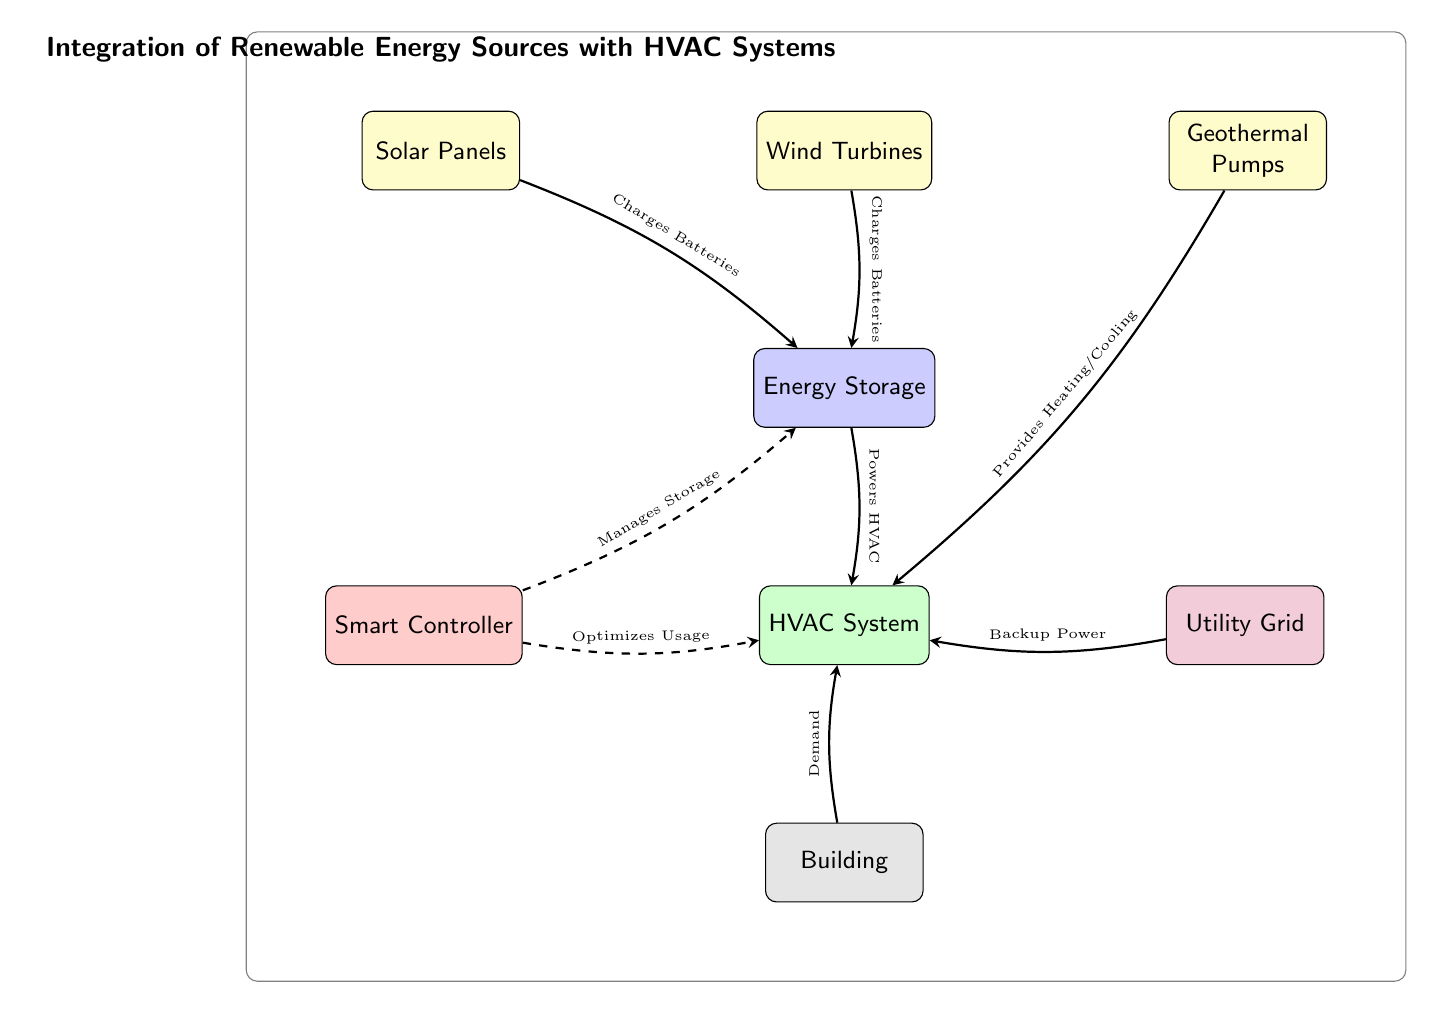What are the energy sources integrated into the HVAC system? The diagram shows three energy sources: Solar Panels, Wind Turbines, and Geothermal Pumps. Each of these is labeled as an energy source, directly connected through arrows to the respective nodes for their functions.
Answer: Solar Panels, Wind Turbines, Geothermal Pumps What function does the Smart Controller serve in this diagram? The Smart Controller is connected to both the HVAC System and the Energy Storage, with arrows indicating its management roles. It is labeled as optimizing usage and managing storage within the system.
Answer: Optimizes Usage, Manages Storage How many energy sources are shown in the diagram? By counting the nodes labeled as energy sources (Solar Panels, Wind Turbines, Geothermal Pumps), there are a total of three distinct sources represented in the diagram.
Answer: 3 What does the Energy Storage do in relation to the HVAC System? The Energy Storage node is connected to the HVAC System via a flow arrow, indicating that it provides power to the HVAC System. The label on the arrow confirms this function explicitly, stating it powers the HVAC.
Answer: Powers HVAC What type of backup does the HVAC System have? The HVAC System is connected to a Utility Grid node with a flow arrow, which indicates that it has backup power supplied from the grid. The label on the arrow specifies this capacity, confirming that the grid acts as a backup.
Answer: Backup Power Which energy source provides heating or cooling directly to the HVAC System? The Geothermal Pumps node has an arrow directly pointing towards the HVAC System, specifically labeled as providing heating/cooling. This means it is a crucial source for temperature regulation in the system.
Answer: Provides Heating/Cooling What entity is at the bottom of the diagram, indicating the overall demand for the HVAC system? At the bottom of the diagram, there is a node labeled 'Building', which is depicted as representing the demand for HVAC services. The flow arrow points from the building to the HVAC, establishing this relationship.
Answer: Building 